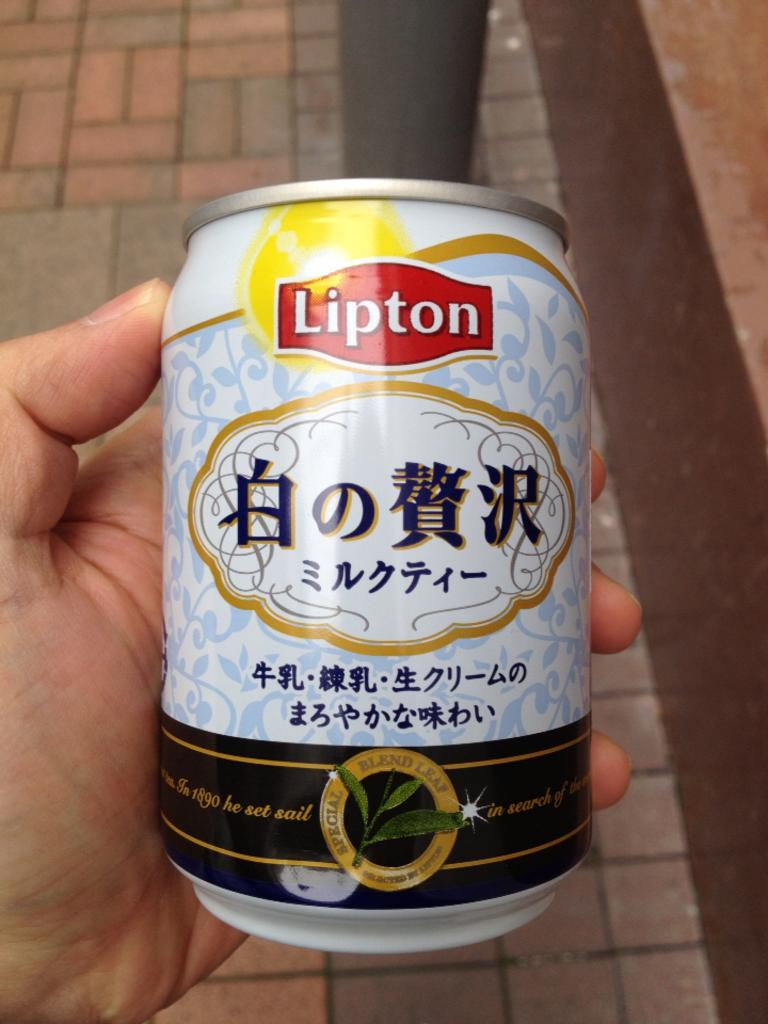<image>
Render a clear and concise summary of the photo. A beverage made by Lipton with some Chinese characters on the can.. 